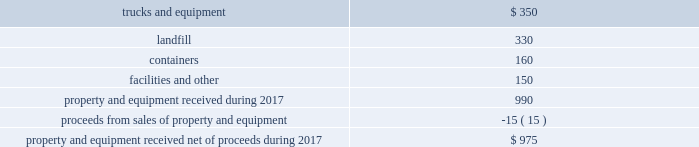We believe that the presentation of adjusted diluted earnings per share , which excludes withdrawal costs 2013 multiemployer pension funds , restructuring charges , loss on extinguishment of debt , and ( gain ) loss on business dispositions and impairments , net , provides an understanding of operational activities before the financial effect of certain items .
We use this measure , and believe investors will find it helpful , in understanding the ongoing performance of our operations separate from items that have a disproportionate effect on our results for a particular period .
We have incurred comparable charges and costs in prior periods , and similar types of adjustments can reasonably be expected to be recorded in future periods .
Our definition of adjusted diluted earnings per share may not be comparable to similarly titled measures presented by other companies .
Property and equipment , net in 2017 , we anticipate receiving approximately $ 975 million of property and equipment , net of proceeds from sales of property and equipment , as follows: .
Results of operations revenue we generate revenue primarily from our solid waste collection operations .
Our remaining revenue is from other services , including transfer station , landfill disposal , recycling , and energy services .
Our residential and small- container commercial collection operations in some markets are based on long-term contracts with municipalities .
Certain of our municipal contracts have annual price escalation clauses that are tied to changes in an underlying base index such as a consumer price index .
We generally provide small-container commercial and large-container industrial collection services to customers under contracts with terms up to three years .
Our transfer stations , landfills and , to a lesser extent , our recycling facilities generate revenue from disposal or tipping fees charged to third parties .
In general , we integrate our recycling operations with our collection operations and obtain revenue from the sale of recycled commodities .
Our revenue from energy services consists mainly of fees we charge for the treatment of liquid and solid waste derived from the production of oil and natural gas .
Other revenue consists primarily of revenue from national accounts , which represents the portion of revenue generated from nationwide or regional contracts in markets outside our operating areas where the associated waste handling services are subcontracted to local operators .
Consequently , substantially all of this revenue is offset with related subcontract costs , which are recorded in cost of operations. .
As part of the sales proceeds net what was the percent of the trucks and equipment? 
Computations: (350 / 975)
Answer: 0.35897. 